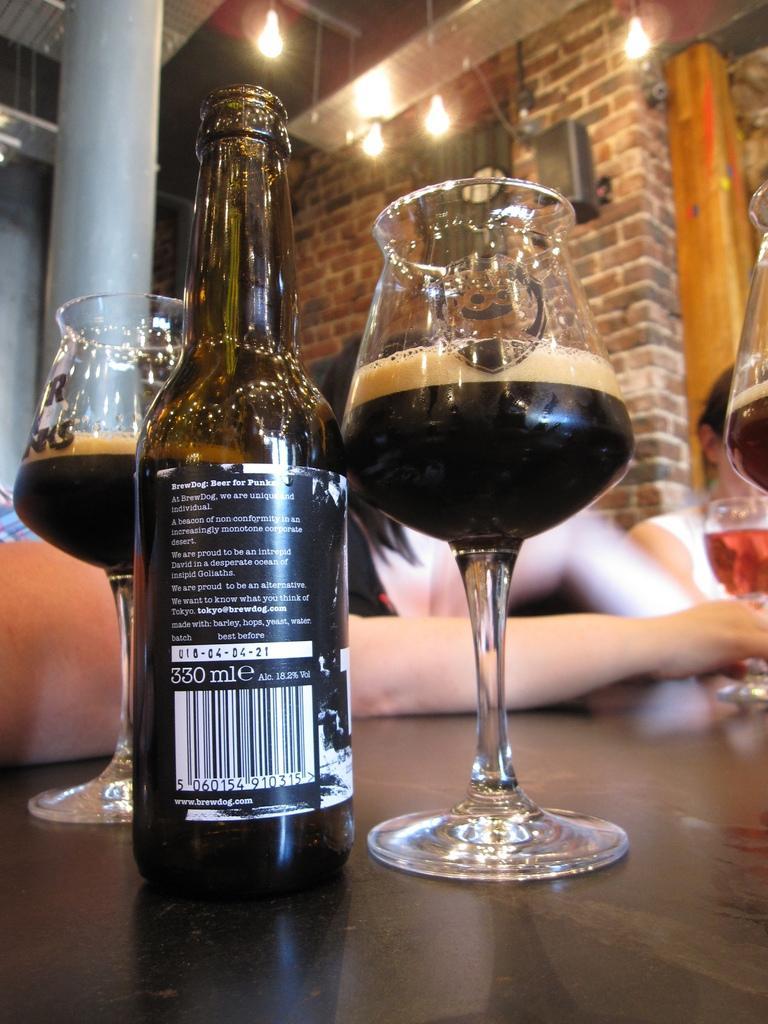Could you give a brief overview of what you see in this image? In this image, In the middle there is a table on that there is a bottle and glasses, In front of the table there are three people. In the background there is a pillar, wall, speakers and light. 